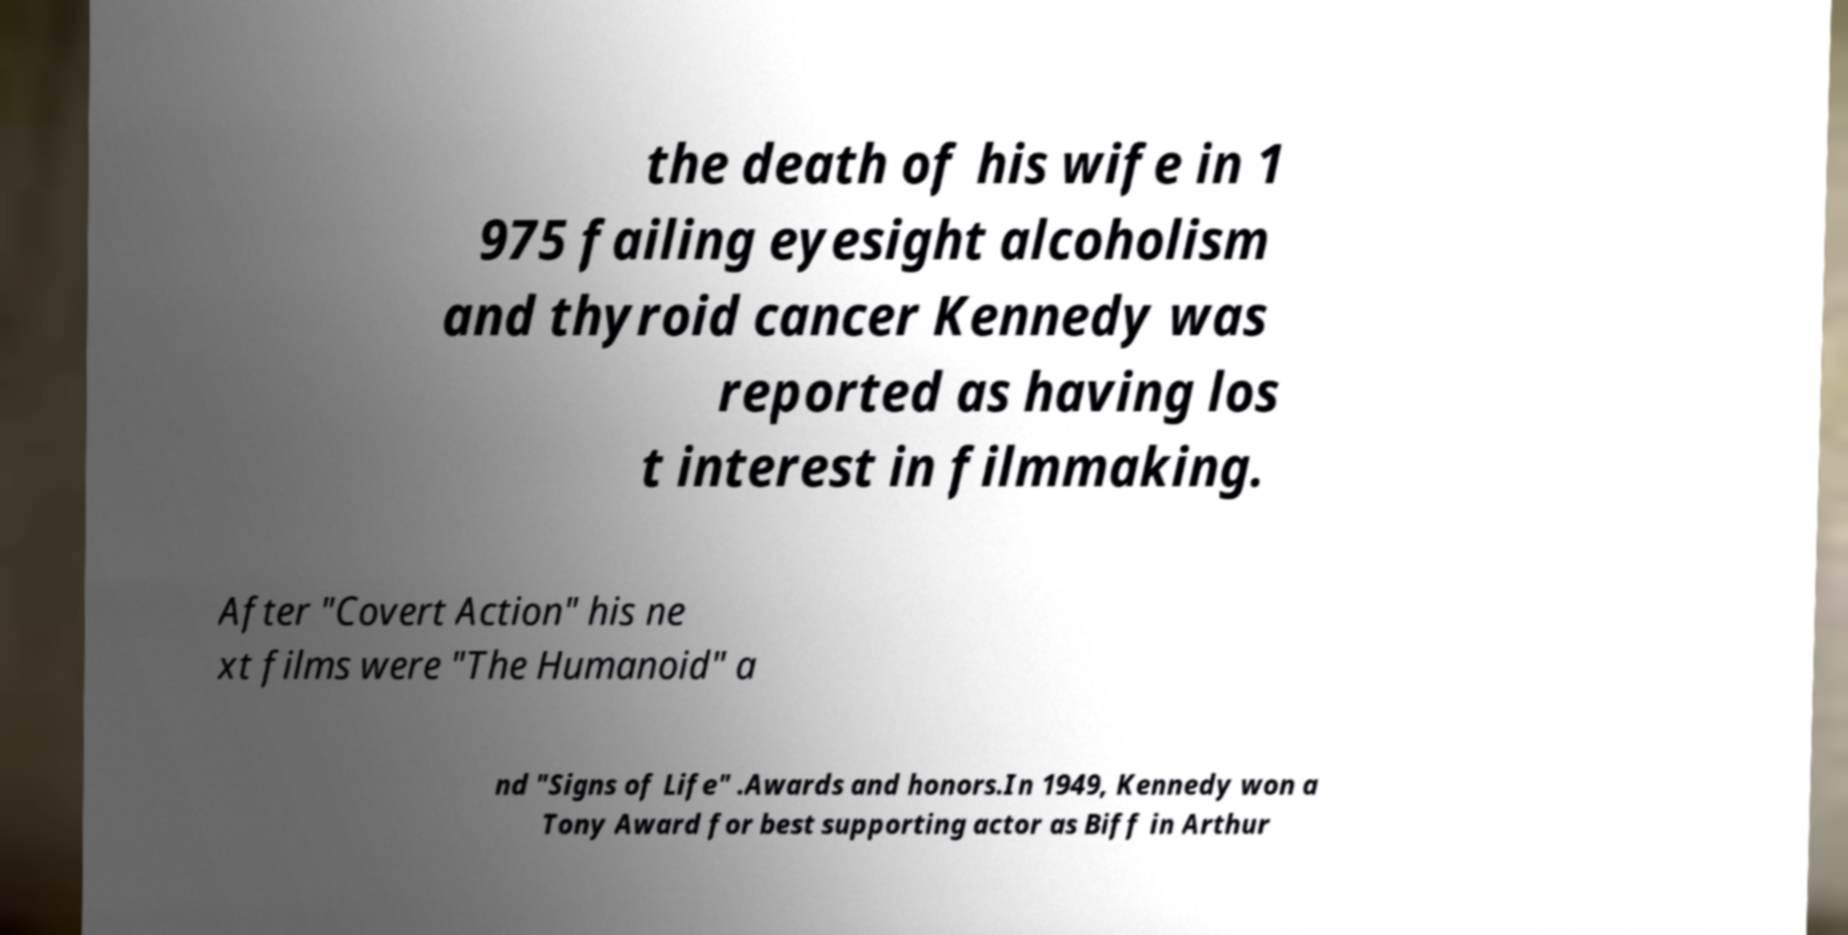Please identify and transcribe the text found in this image. the death of his wife in 1 975 failing eyesight alcoholism and thyroid cancer Kennedy was reported as having los t interest in filmmaking. After "Covert Action" his ne xt films were "The Humanoid" a nd "Signs of Life" .Awards and honors.In 1949, Kennedy won a Tony Award for best supporting actor as Biff in Arthur 